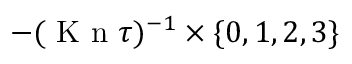Convert formula to latex. <formula><loc_0><loc_0><loc_500><loc_500>- ( { K n } \tau ) ^ { - 1 } \times \{ 0 , 1 , 2 , 3 \}</formula> 